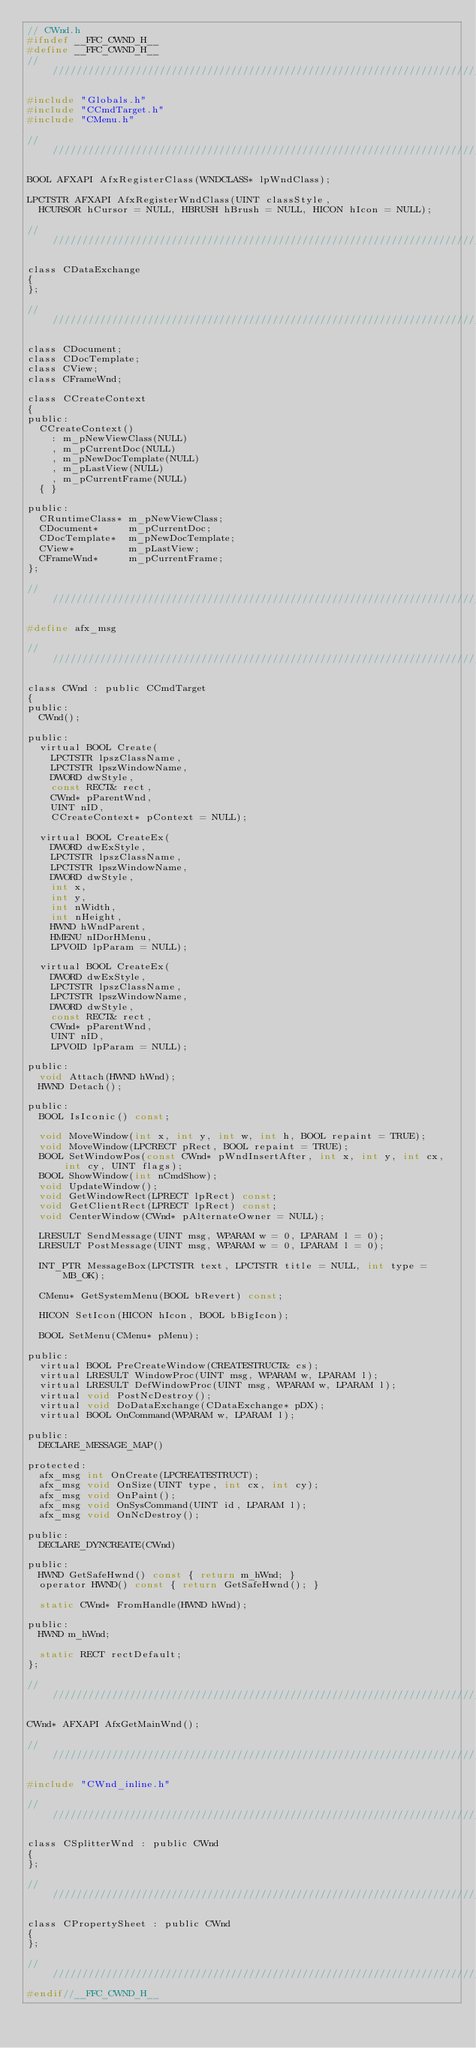Convert code to text. <code><loc_0><loc_0><loc_500><loc_500><_C_>// CWnd.h
#ifndef __FFC_CWND_H__
#define __FFC_CWND_H__
///////////////////////////////////////////////////////////////////////////

#include "Globals.h"
#include "CCmdTarget.h"
#include "CMenu.h"

///////////////////////////////////////////////////////////////////////////

BOOL AFXAPI AfxRegisterClass(WNDCLASS* lpWndClass);

LPCTSTR AFXAPI AfxRegisterWndClass(UINT classStyle,
	HCURSOR hCursor = NULL, HBRUSH hBrush = NULL, HICON hIcon = NULL);

///////////////////////////////////////////////////////////////////////////

class CDataExchange
{
};

///////////////////////////////////////////////////////////////////////////

class CDocument;
class CDocTemplate;
class CView;
class CFrameWnd;

class CCreateContext
{
public:
	CCreateContext()
		: m_pNewViewClass(NULL)
		, m_pCurrentDoc(NULL)
		, m_pNewDocTemplate(NULL)
		, m_pLastView(NULL)
		, m_pCurrentFrame(NULL)
	{ }

public:
	CRuntimeClass* m_pNewViewClass;
	CDocument*     m_pCurrentDoc;
	CDocTemplate*  m_pNewDocTemplate;
	CView*         m_pLastView;
	CFrameWnd*     m_pCurrentFrame;
};

///////////////////////////////////////////////////////////////////////////

#define afx_msg

///////////////////////////////////////////////////////////////////////////

class CWnd : public CCmdTarget
{
public:
	CWnd();

public:
	virtual BOOL Create(
		LPCTSTR lpszClassName,
		LPCTSTR lpszWindowName,
		DWORD dwStyle,
		const RECT& rect,
		CWnd* pParentWnd,
		UINT nID,
		CCreateContext* pContext = NULL);
	
	virtual BOOL CreateEx(
		DWORD dwExStyle,
		LPCTSTR lpszClassName,
		LPCTSTR lpszWindowName,
		DWORD dwStyle,
		int x,
		int y,
		int nWidth,
		int nHeight,
		HWND hWndParent,
		HMENU nIDorHMenu,
		LPVOID lpParam = NULL);
	
	virtual BOOL CreateEx(
		DWORD dwExStyle,
		LPCTSTR lpszClassName,
		LPCTSTR lpszWindowName,
		DWORD dwStyle,
		const RECT& rect,
		CWnd* pParentWnd,
		UINT nID,
		LPVOID lpParam = NULL);

public:
	void Attach(HWND hWnd);
	HWND Detach();

public:
	BOOL IsIconic() const;

	void MoveWindow(int x, int y, int w, int h, BOOL repaint = TRUE);
	void MoveWindow(LPCRECT pRect, BOOL repaint = TRUE);
	BOOL SetWindowPos(const CWnd* pWndInsertAfter, int x, int y, int cx, int cy, UINT flags);
	BOOL ShowWindow(int nCmdShow);
	void UpdateWindow();
	void GetWindowRect(LPRECT lpRect) const;
	void GetClientRect(LPRECT lpRect) const;
	void CenterWindow(CWnd* pAlternateOwner = NULL);

	LRESULT SendMessage(UINT msg, WPARAM w = 0, LPARAM l = 0);
	LRESULT PostMessage(UINT msg, WPARAM w = 0, LPARAM l = 0);

	INT_PTR MessageBox(LPCTSTR text, LPCTSTR title = NULL, int type = MB_OK);

	CMenu* GetSystemMenu(BOOL bRevert) const;

	HICON SetIcon(HICON hIcon, BOOL bBigIcon);

	BOOL SetMenu(CMenu* pMenu);

public:
	virtual BOOL PreCreateWindow(CREATESTRUCT& cs);
	virtual LRESULT WindowProc(UINT msg, WPARAM w, LPARAM l);
	virtual LRESULT DefWindowProc(UINT msg, WPARAM w, LPARAM l);
	virtual void PostNcDestroy();
	virtual void DoDataExchange(CDataExchange* pDX);
	virtual BOOL OnCommand(WPARAM w, LPARAM l);

public:
	DECLARE_MESSAGE_MAP()

protected:
	afx_msg int OnCreate(LPCREATESTRUCT);
	afx_msg void OnSize(UINT type, int cx, int cy);
	afx_msg void OnPaint();
	afx_msg void OnSysCommand(UINT id, LPARAM l);
	afx_msg void OnNcDestroy();

public:
	DECLARE_DYNCREATE(CWnd)

public:
	HWND GetSafeHwnd() const { return m_hWnd; }
	operator HWND() const { return GetSafeHwnd(); }

	static CWnd* FromHandle(HWND hWnd);

public:
	HWND m_hWnd;

	static RECT rectDefault;
};

///////////////////////////////////////////////////////////////////////////

CWnd* AFXAPI AfxGetMainWnd();

///////////////////////////////////////////////////////////////////////////

#include "CWnd_inline.h"

///////////////////////////////////////////////////////////////////////////

class CSplitterWnd : public CWnd
{
};

///////////////////////////////////////////////////////////////////////////

class CPropertySheet : public CWnd
{
};

///////////////////////////////////////////////////////////////////////////
#endif//__FFC_CWND_H__

</code> 